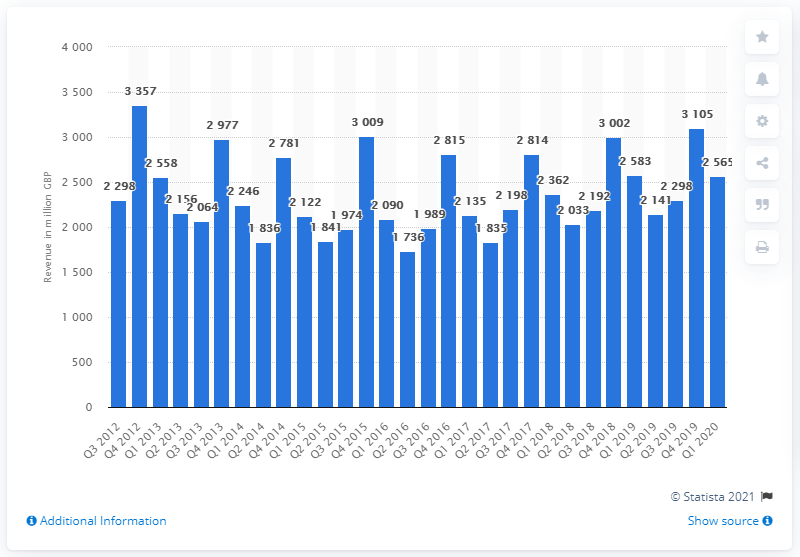List a handful of essential elements in this visual. The IT sector generated approximately $25,650,000 in revenue during the first quarter of 2020. 